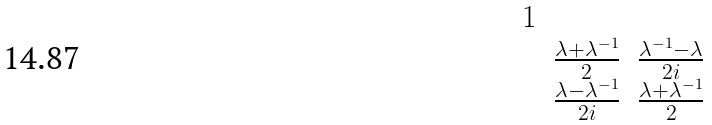<formula> <loc_0><loc_0><loc_500><loc_500>\begin{matrix} 1 & & \\ & \frac { \lambda + \lambda ^ { - 1 } } { 2 } & \frac { \lambda ^ { - 1 } - \lambda } { 2 i } \\ & \frac { \lambda - \lambda ^ { - 1 } } { 2 i } & \frac { \lambda + \lambda ^ { - 1 } } { 2 } \end{matrix}</formula> 